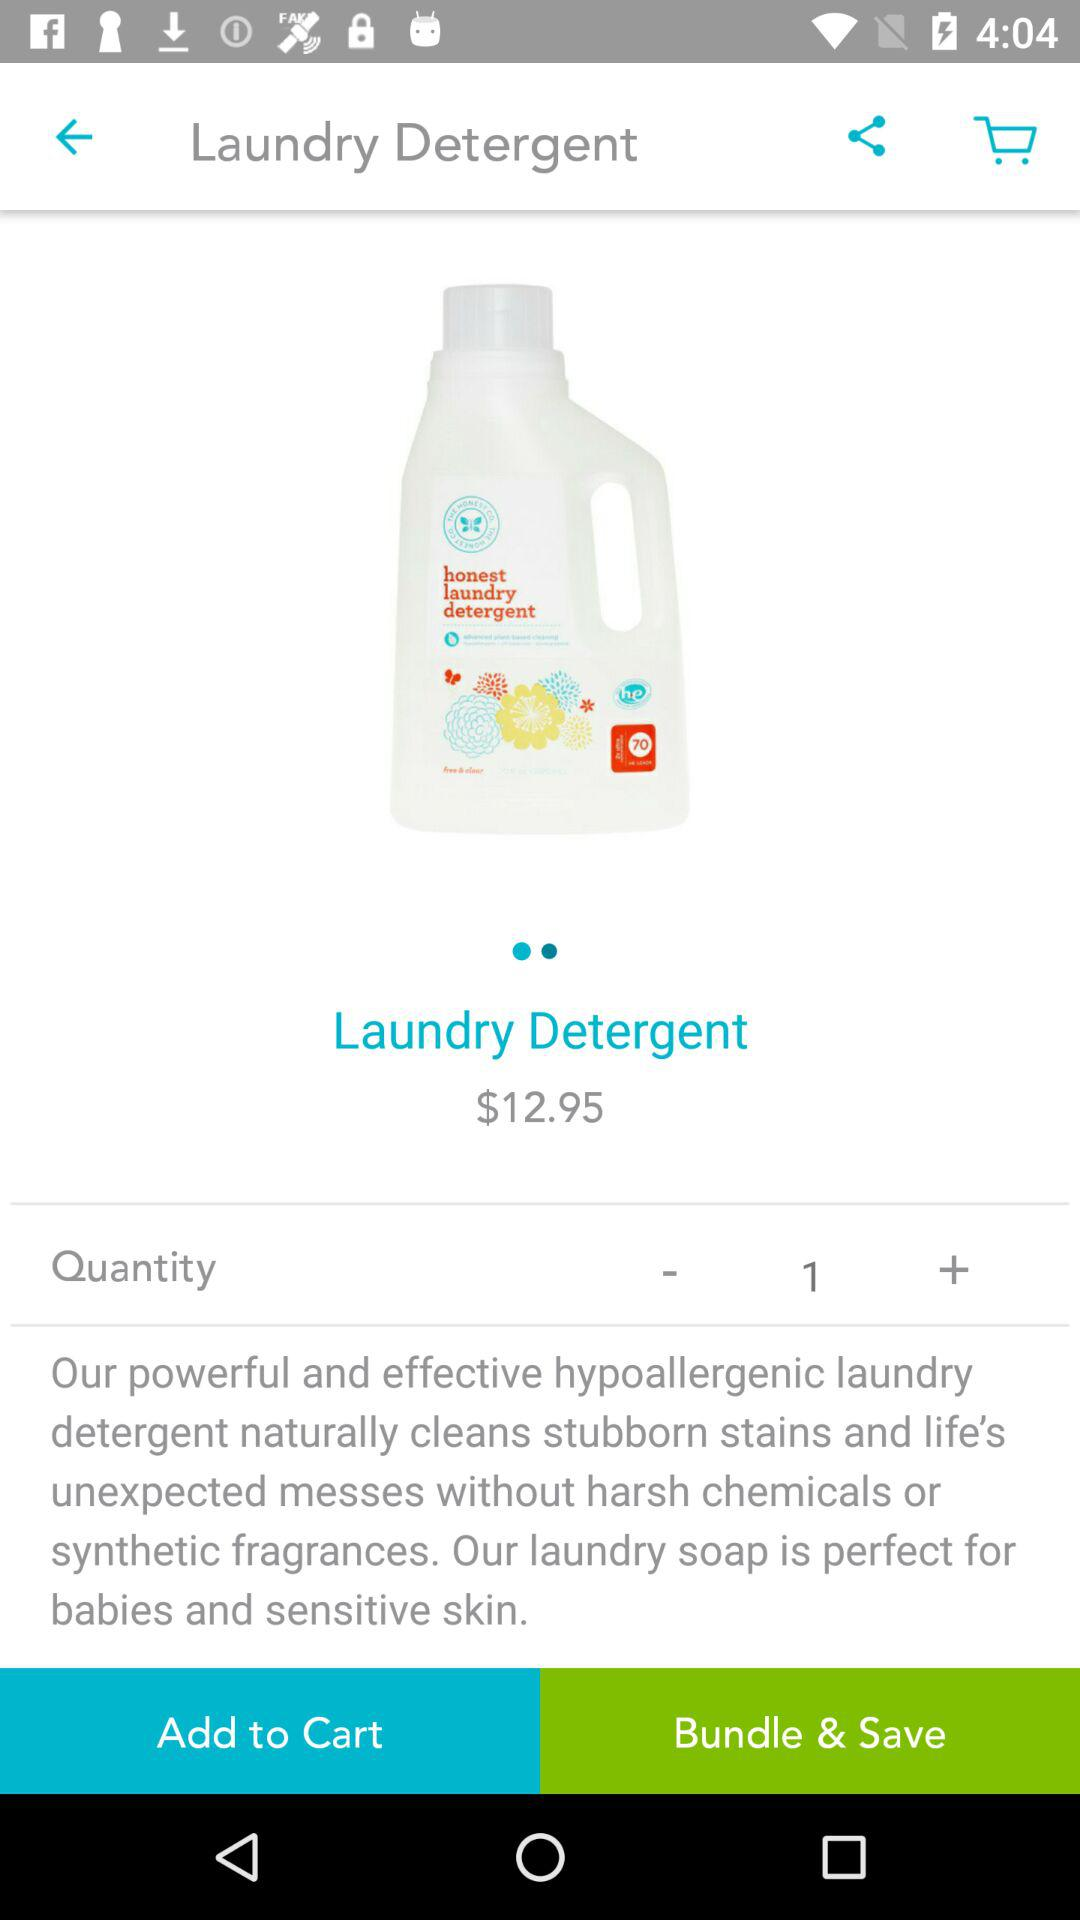What quantity is selected? The selected quantity is 1. 